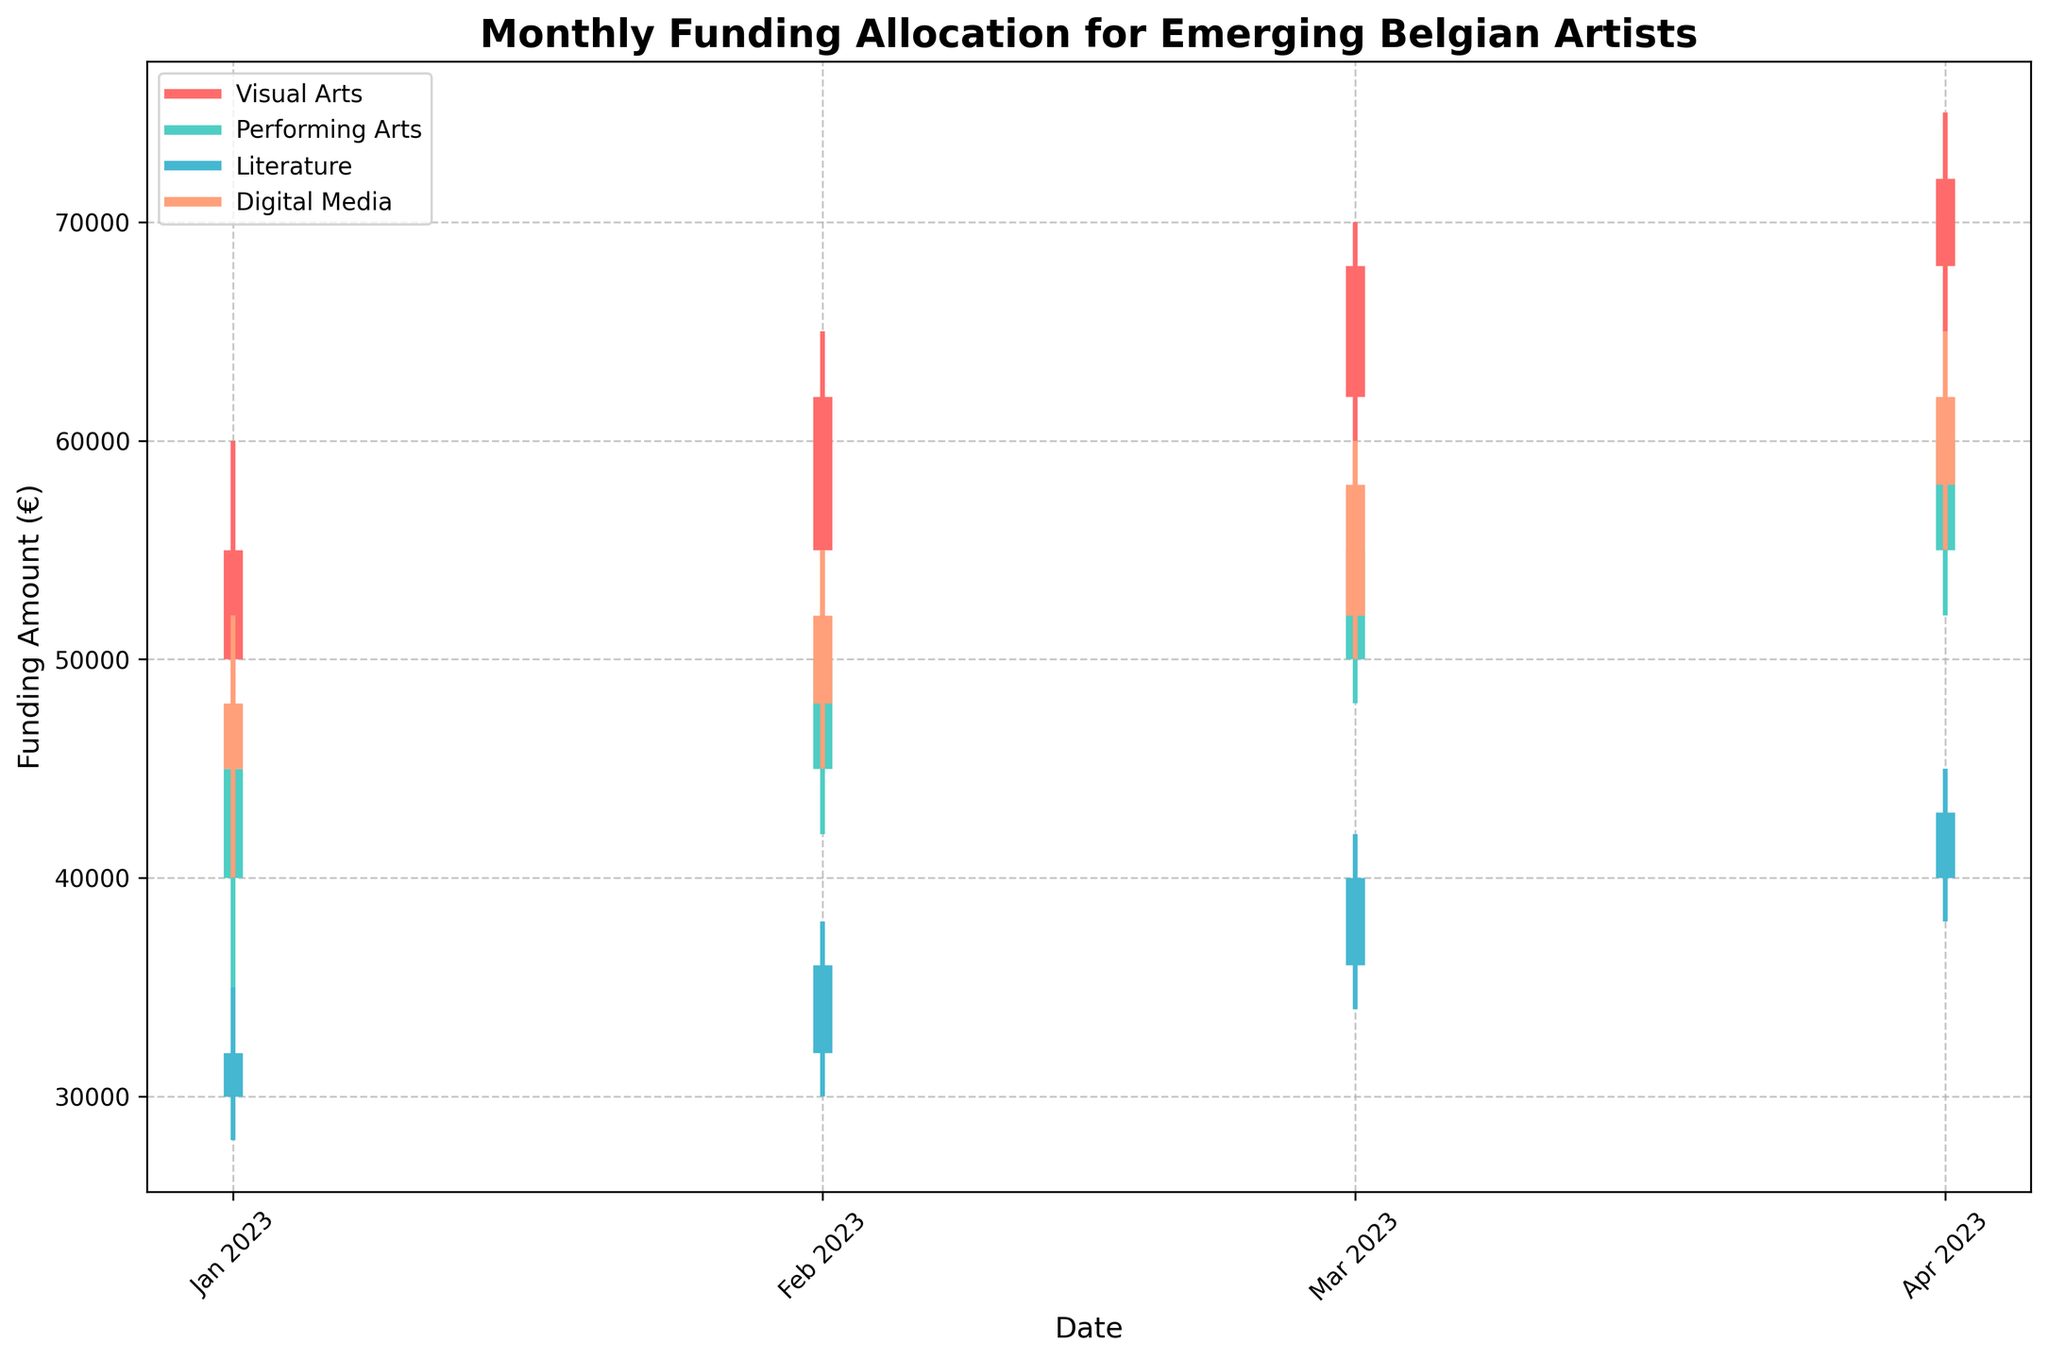What's the title of the figure? The title of the figure is prominently displayed at the top in bold. It reads 'Monthly Funding Allocation for Emerging Belgian Artists'.
Answer: Monthly Funding Allocation for Emerging Belgian Artists What are the categories represented in the figure? The figure uses colors to distinguish four categories, as indicated by the legend in the upper left. The categories are Visual Arts, Performing Arts, Literature, and Digital Media.
Answer: Visual Arts, Performing Arts, Literature, Digital Media What is the color used for the 'Literature' category? According to the legend, each category is represented by a distinct color. The color for the 'Literature' category is light blue.
Answer: light blue On which date did 'Digital Media' receive the highest funding amount? To find the highest funding, we need to look at the 'High' value for 'Digital Media' across the dates. The highest 'High' is €65,000, which occurred on 2023-04-01.
Answer: 2023-04-01 What was the lowest funding amount for 'Performing Arts' in February 2023? For the 'Performing Arts' in February 2023, we need to locate the 'Low' value for that month. The 'Low' funding amount is €42,000.
Answer: €42,000 Compare the 'Close' values for 'Visual Arts' in January and March 2023. Which month had a higher closing value? The 'Close' values for 'Visual Arts' in January 2023 and March 2023 are €55,000 and €68,000, respectively. March 2023 has a higher closing value.
Answer: March 2023 What is the average 'Open' value for 'Literature' across all months? The 'Open' values for 'Literature' are €30,000, €32,000, €36,000, and €40,000. The sum is €138,000. Dividing by the 4 months gives an average: 138,000 / 4 = €34,500.
Answer: €34,500 For 'Visual Arts', what is the difference between the 'High' value in April and the 'Low' value in February? April’s 'High' value is €75,000 and February’s 'Low' value is €50,000. The difference is 75,000 - 50,000 = €25,000.
Answer: €25,000 Which category had the highest 'Close' value in April 2023? The 'Close' values for April 2023 are €72,000 (Visual Arts), €60,000 (Performing Arts), €43,000 (Literature), and €62,000 (Digital Media). The highest 'Close' value is for Visual Arts.
Answer: Visual Arts How did the 'Close' value for 'Performing Arts' change from January to April 2023? The 'Close' value for 'Performing Arts' in January was €45,000. In April, it was €60,000. The change is an increase of 60,000 - 45,000 = €15,000.
Answer: Increased by €15,000 